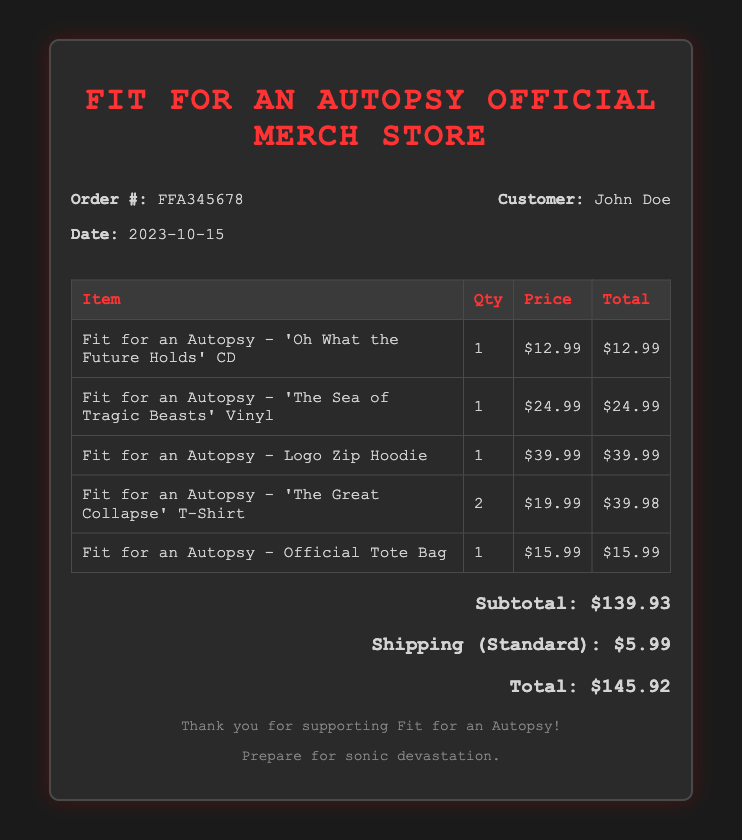what is the order number? The order number is mentioned in the document as a unique identifier for the transaction.
Answer: FFA345678 what is the date of the order? The date indicates when the order was placed and is provided in the document.
Answer: 2023-10-15 who is the customer? The customer's name is presented in the bill header and identifies who made the purchase.
Answer: John Doe how many 'The Great Collapse' T-Shirts were purchased? The quantity of a specific item is listed in the table of items purchased.
Answer: 2 what is the price of the Logo Zip Hoodie? The price of a specific merchandise item is detailed in the table.
Answer: $39.99 what is the subtotal before shipping? The subtotal is the sum of all items prior to adding shipping charges.
Answer: $139.93 what is the shipping charge? The shipping charge for the order is explicitly stated in the document.
Answer: $5.99 what is the total amount due for the order? The total is calculated by adding the subtotal and shipping charge, found at the bottom of the document.
Answer: $145.92 what item is associated with the highest price? The document lists prices for various items, and the highest price can be determined from the table.
Answer: Fit for an Autopsy - Logo Zip Hoodie 